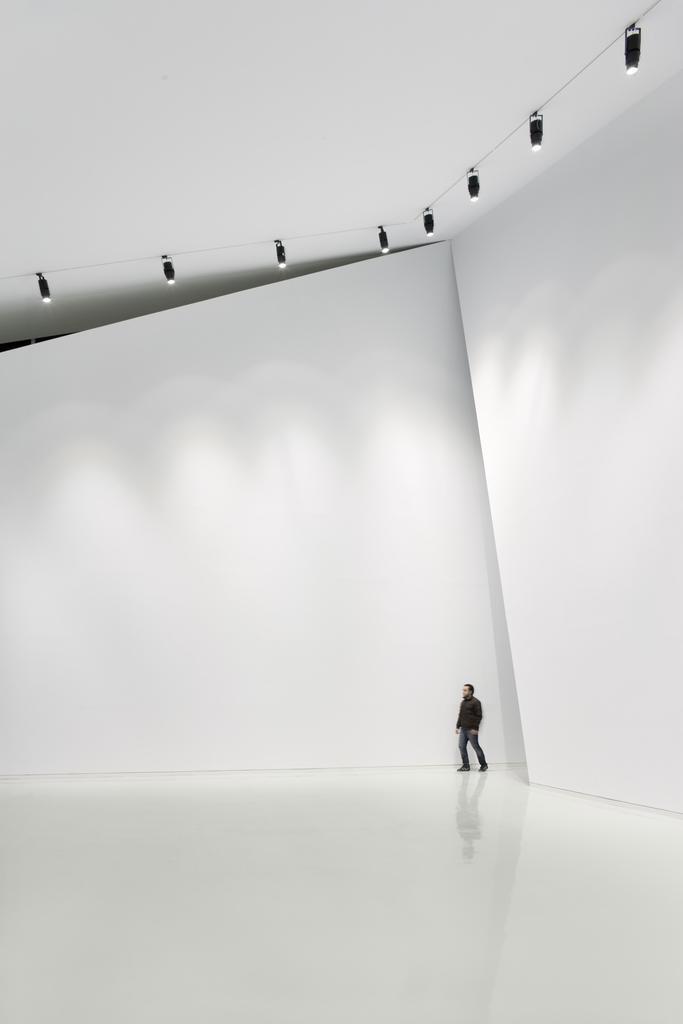Please provide a concise description of this image. This is completely an indoor picture. In this picture we can see a man wearing a black jacket and shoes. Here we can see the reflection of the man. On the top we can see a ceiling with few lights. The walls are in white colour. 